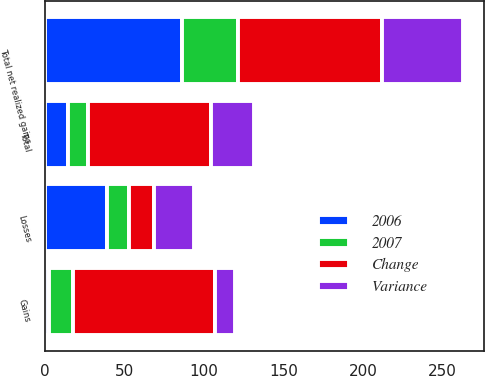Convert chart. <chart><loc_0><loc_0><loc_500><loc_500><stacked_bar_chart><ecel><fcel>Gains<fcel>Total<fcel>Losses<fcel>Total net realized gains<nl><fcel>2006<fcel>2.6<fcel>14.3<fcel>38.8<fcel>86.3<nl><fcel>2007<fcel>14.9<fcel>12.9<fcel>13.9<fcel>35.1<nl><fcel>Change<fcel>89.6<fcel>77.2<fcel>15.9<fcel>90.3<nl><fcel>Variance<fcel>12.3<fcel>27.2<fcel>24.9<fcel>51.2<nl></chart> 